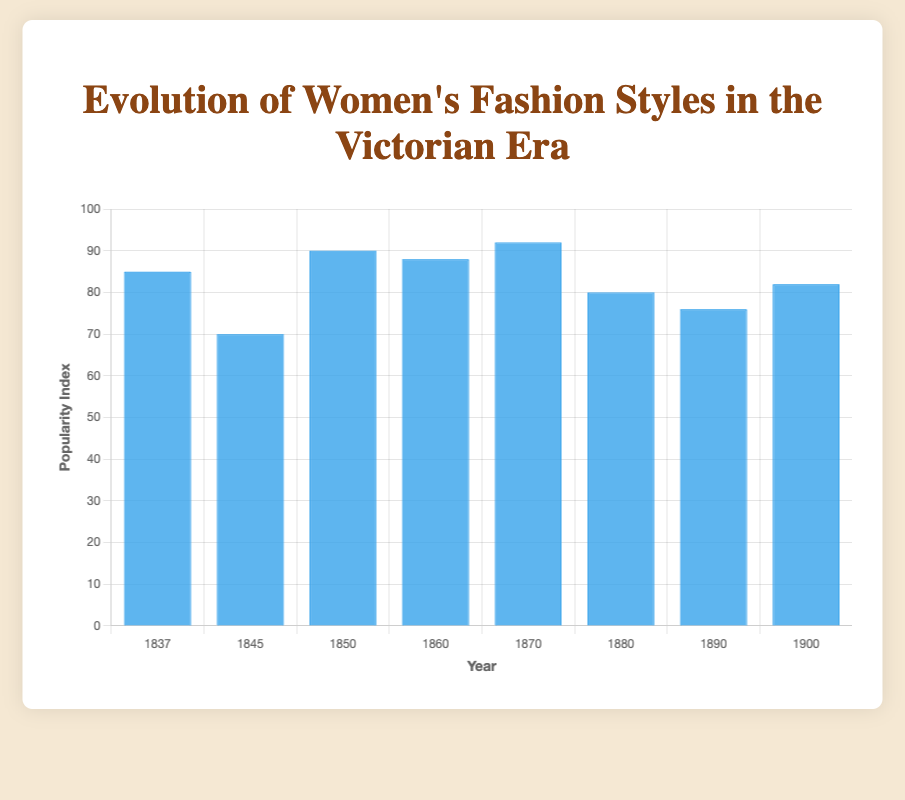Which year had the highest popularity index for Victorian fashion styles? The bar representing the year 1870 is the tallest, indicating the highest popularity index of 92.
Answer: 1870 Which year had a higher popularity index, 1860 or 1890? The bar for 1860 (Bodices) is taller than the bar for 1890 (Leg of Mutton Sleeves). The popularity index for 1860 is 88, and for 1890, it is 76.
Answer: 1860 By how many points does the popularity index of Crinolines in 1850 exceed that of Low Necklines in 1845? The popularity index for Crinolines in 1850 is 90 and for Low Necklines in 1845 is 70. The difference is 90 - 70.
Answer: 20 What's the average popularity index of Victorian fashion styles for the years 1837, 1845, 1850, and 1860? Adding the popularity indexes for these years: 85 (1837) + 70 (1845) + 90 (1850) + 88 (1860) = 333. Dividing by 4 gives 333 / 4.
Answer: 83.25 Which fashion style in 1880 had a popularity index lower than 1837? The bar for 1880 (Tighter Corsets) is shorter than the bar for 1837 (Gigot Sleeves). The popularity index for 1880 is 80, and for 1837, it is 85.
Answer: Tighter Corsets Arrange the years 1850, 1870, and 1900 in descending order of their popularity indexes. The popularity index for 1850 (Crinolines) is 90, for 1870 (Bustles) is 92, and for 1900 (S-Bend Corsets) is 82. Arranging them in descending order: 92, 90, 82.
Answer: 1870, 1850, 1900 What was the popularity index change from the style in 1880 to the style in 1900? The popularity index for 1880 (Tighter Corsets) is 80 and for 1900 (S-Bend Corsets) is 82. The change is 82 - 80.
Answer: 2 What is the median popularity index of the fashion styles listed? The popularity indexes in ascending order: 70, 76, 80, 82, 85, 88, 90, 92. The median is the average of the 4th and 5th values: (82 + 85) / 2.
Answer: 83.5 